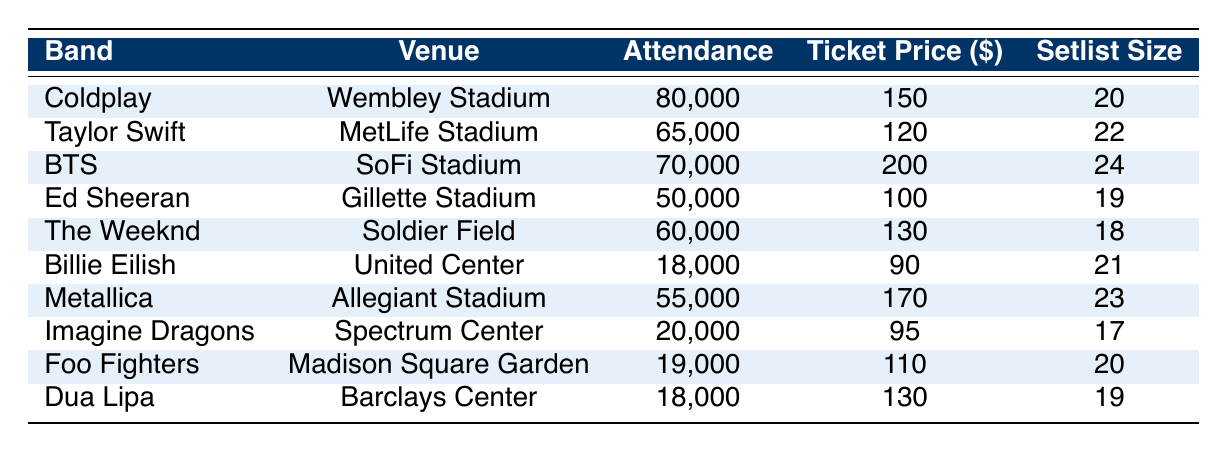What was the highest concert attendance in 2022? By looking at the Attendance column in the table, we see that Coldplay had the highest attendance at 80,000.
Answer: 80,000 Which band had the lowest attendance? The lowest attendance is found in the entry for Billie Eilish, which shows 18,000 people attended her concert.
Answer: 18,000 What is the ticket price for BTS concert? The Ticket Price column for BTS indicates that the ticket price for their concert was $200.
Answer: $200 How many bands had an attendance of over 60,000? By counting the entries with attendance greater than 60,000, we find 4 bands: Coldplay, BTS, Taylor Swift, and The Weeknd.
Answer: 4 What was the average ticket price for the concerts? To calculate the average ticket price, add up the ticket prices ($150 + $120 + $200 + $100 + $130 + $90 + $170 + $95 + $110 + $130 = $1,295) and divide by the number of concerts (10), resulting in an average of $129.50.
Answer: $129.50 Did Ed Sheeran have the highest setlist size? No, BTS had the highest setlist size of 24, while Ed Sheeran's setlist size was 19.
Answer: No Which venue had the most attendees? The venue with the highest attendance is Wembley Stadium where Coldplay performed, attracting 80,000 fans.
Answer: Wembley Stadium What is the total attendance for all concerts? The total attendance is calculated by summing all attendance values (80,000 + 65,000 + 70,000 + 50,000 + 60,000 + 18,000 + 55,000 + 20,000 + 19,000 + 18,000 = 455,000).
Answer: 455,000 What is the difference in attendance between Coldplay and Ed Sheeran? By calculating the difference in attendance, we find Coldplay's 80,000 minus Ed Sheeran's 50,000 equals 30,000.
Answer: 30,000 Which band had a setlist size of 22? Taylor Swift is the band that had a setlist size of 22, as indicated in the table.
Answer: Taylor Swift 